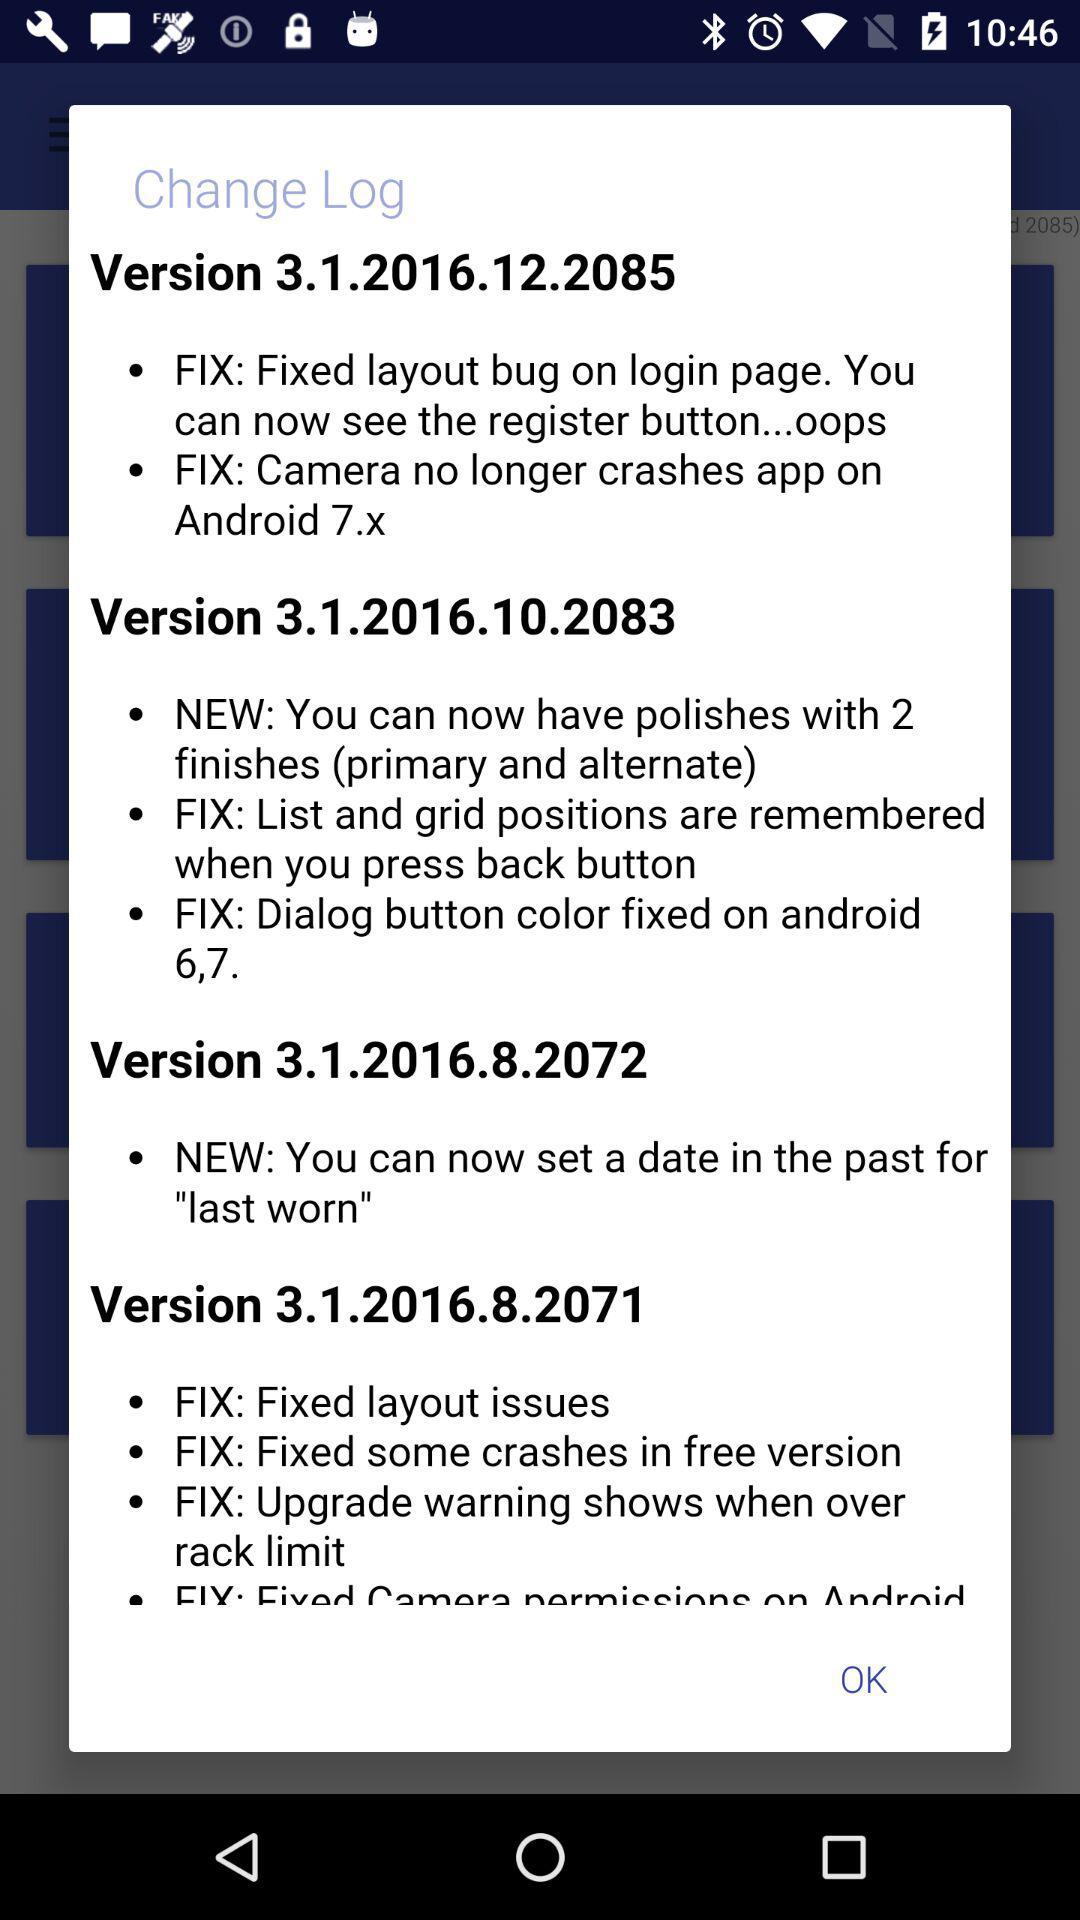In which version are there fixed layout issues? Fixed layout issues are in version 3.1.2016.8.2071. 